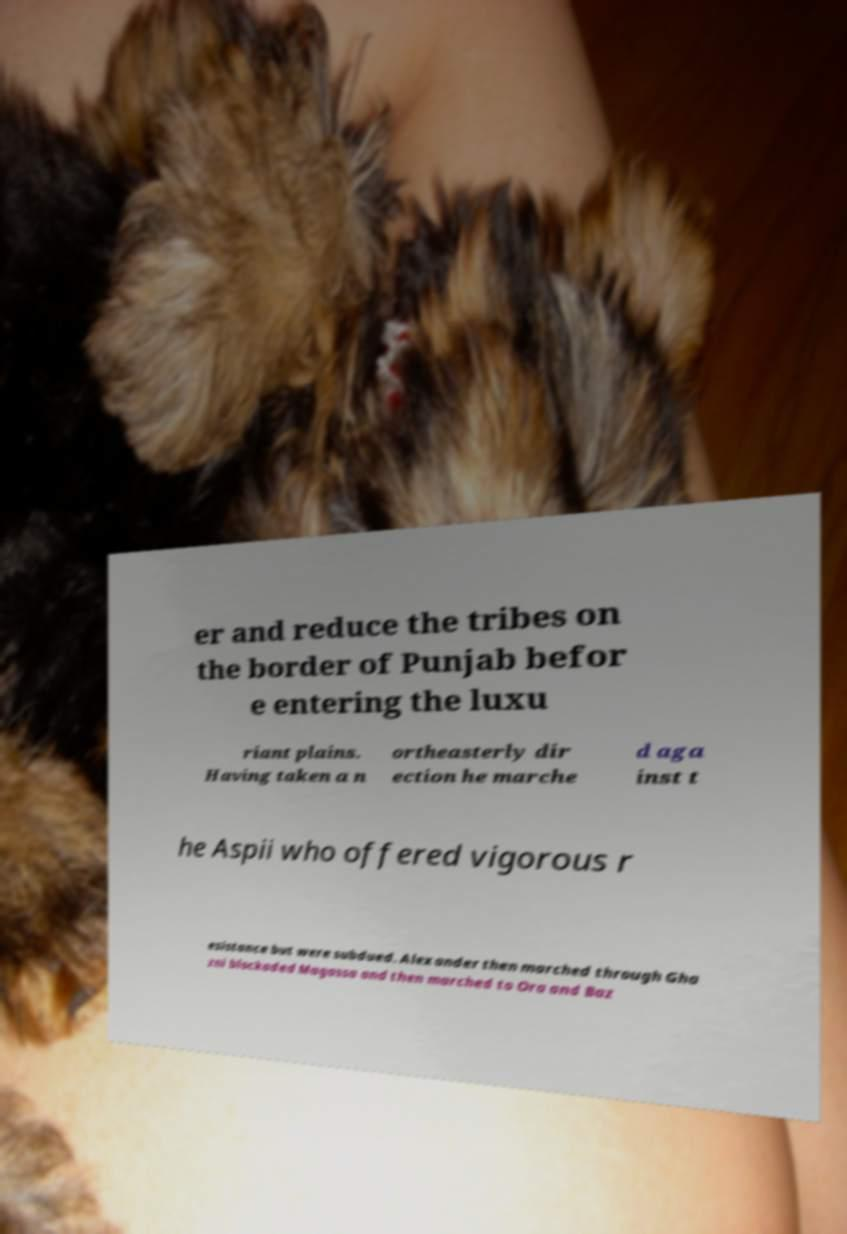Could you assist in decoding the text presented in this image and type it out clearly? er and reduce the tribes on the border of Punjab befor e entering the luxu riant plains. Having taken a n ortheasterly dir ection he marche d aga inst t he Aspii who offered vigorous r esistance but were subdued. Alexander then marched through Gha zni blockaded Magassa and then marched to Ora and Baz 